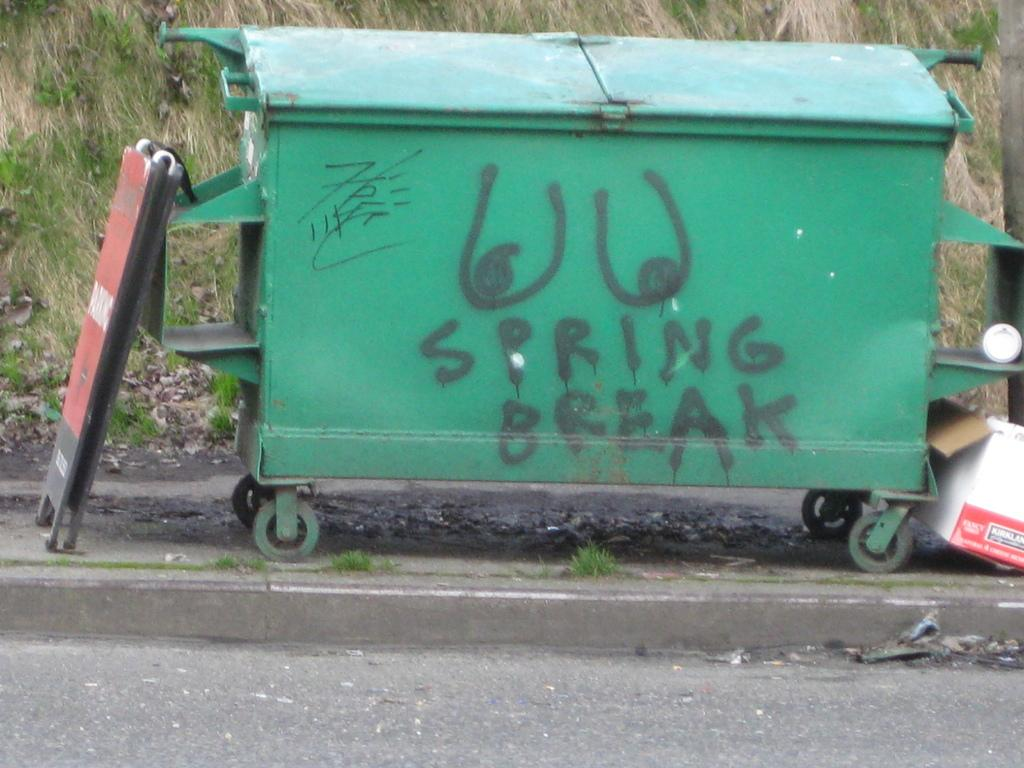<image>
Create a compact narrative representing the image presented. A green dumpster with a lewd picture that says SPRING BREAK. 